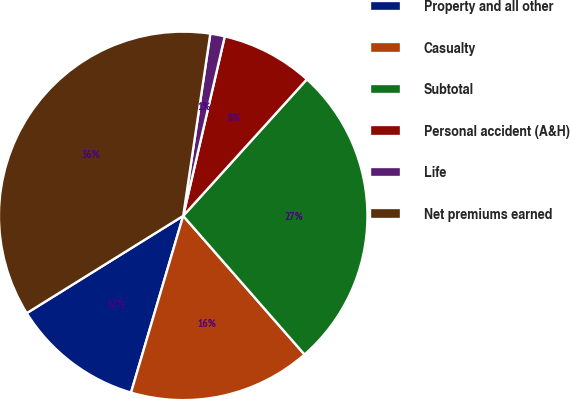Convert chart to OTSL. <chart><loc_0><loc_0><loc_500><loc_500><pie_chart><fcel>Property and all other<fcel>Casualty<fcel>Subtotal<fcel>Personal accident (A&H)<fcel>Life<fcel>Net premiums earned<nl><fcel>11.58%<fcel>16.01%<fcel>26.85%<fcel>8.09%<fcel>1.27%<fcel>36.21%<nl></chart> 